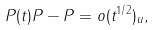Convert formula to latex. <formula><loc_0><loc_0><loc_500><loc_500>P ( t ) P - P = o ( t ^ { 1 / 2 } ) _ { u } ,</formula> 